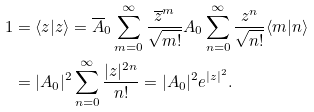Convert formula to latex. <formula><loc_0><loc_0><loc_500><loc_500>1 & = \langle z | z \rangle = \overline { A } _ { 0 } \sum _ { m = 0 } ^ { \infty } \frac { \overline { z } ^ { m } } { \sqrt { m ! } } A _ { 0 } \sum _ { n = 0 } ^ { \infty } \frac { z ^ { n } } { \sqrt { n ! } } \langle m | n \rangle \\ & = | A _ { 0 } | ^ { 2 } \sum _ { n = 0 } ^ { \infty } \frac { | z | ^ { 2 n } } { n ! } = | A _ { 0 } | ^ { 2 } e ^ { | z | ^ { 2 } } .</formula> 